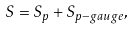<formula> <loc_0><loc_0><loc_500><loc_500>S = S _ { p } + S _ { p - g a u g e } ,</formula> 